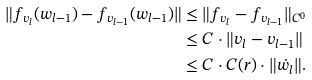Convert formula to latex. <formula><loc_0><loc_0><loc_500><loc_500>\| f _ { v _ { l } } ( w _ { l - 1 } ) - f _ { v _ { l - 1 } } ( w _ { l - 1 } ) \| & \leq \| f _ { v _ { l } } - f _ { v _ { l - 1 } } \| _ { C ^ { 0 } } \\ & \leq C \cdot \| v _ { l } - v _ { l - 1 } \| \\ & \leq C \cdot C ( r ) \cdot \| \dot { w } _ { l } \| .</formula> 